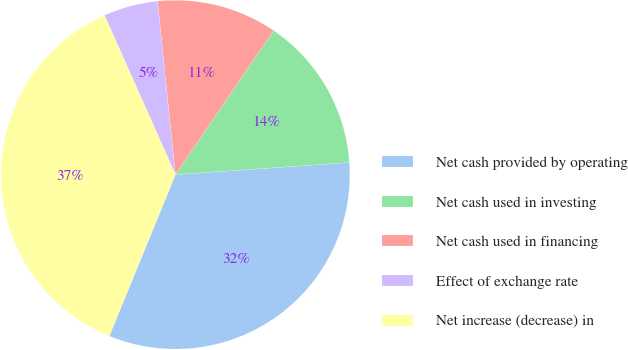Convert chart to OTSL. <chart><loc_0><loc_0><loc_500><loc_500><pie_chart><fcel>Net cash provided by operating<fcel>Net cash used in investing<fcel>Net cash used in financing<fcel>Effect of exchange rate<fcel>Net increase (decrease) in<nl><fcel>32.3%<fcel>14.37%<fcel>11.16%<fcel>5.03%<fcel>37.15%<nl></chart> 